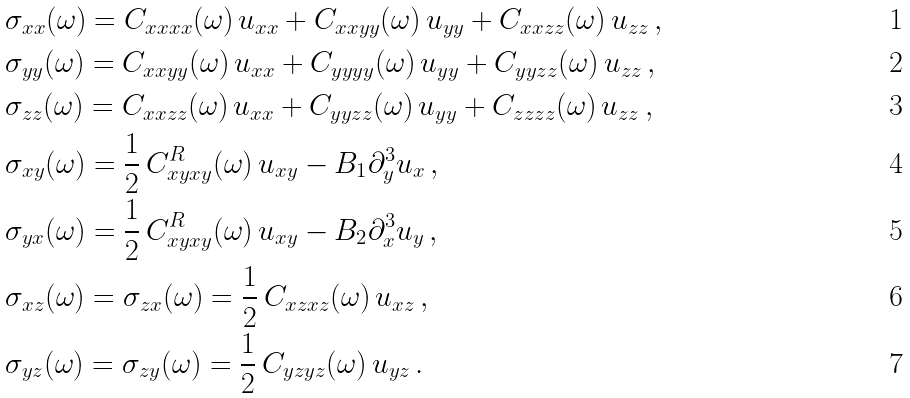<formula> <loc_0><loc_0><loc_500><loc_500>& \sigma _ { x x } ( \omega ) = C _ { x x x x } ( \omega ) \, u _ { x x } + C _ { x x y y } ( \omega ) \, u _ { y y } + C _ { x x z z } ( \omega ) \, u _ { z z } \, , \\ & \sigma _ { y y } ( \omega ) = C _ { x x y y } ( \omega ) \, u _ { x x } + C _ { y y y y } ( \omega ) \, u _ { y y } + C _ { y y z z } ( \omega ) \, u _ { z z } \, , \\ & \sigma _ { z z } ( \omega ) = C _ { x x z z } ( \omega ) \, u _ { x x } + C _ { y y z z } ( \omega ) \, u _ { y y } + C _ { z z z z } ( \omega ) \, u _ { z z } \, , \\ & \sigma _ { x y } ( \omega ) = \frac { 1 } { 2 } \, C _ { x y x y } ^ { R } ( \omega ) \, u _ { x y } - B _ { 1 } \partial _ { y } ^ { 3 } u _ { x } \, , \\ & \sigma _ { y x } ( \omega ) = \frac { 1 } { 2 } \, C _ { x y x y } ^ { R } ( \omega ) \, u _ { x y } - B _ { 2 } \partial _ { x } ^ { 3 } u _ { y } \, , \\ & \sigma _ { x z } ( \omega ) = \sigma _ { z x } ( \omega ) = \frac { 1 } { 2 } \, C _ { x z x z } ( \omega ) \, u _ { x z } \, , \\ & \sigma _ { y z } ( \omega ) = \sigma _ { z y } ( \omega ) = \frac { 1 } { 2 } \, C _ { y z y z } ( \omega ) \, u _ { y z } \, .</formula> 